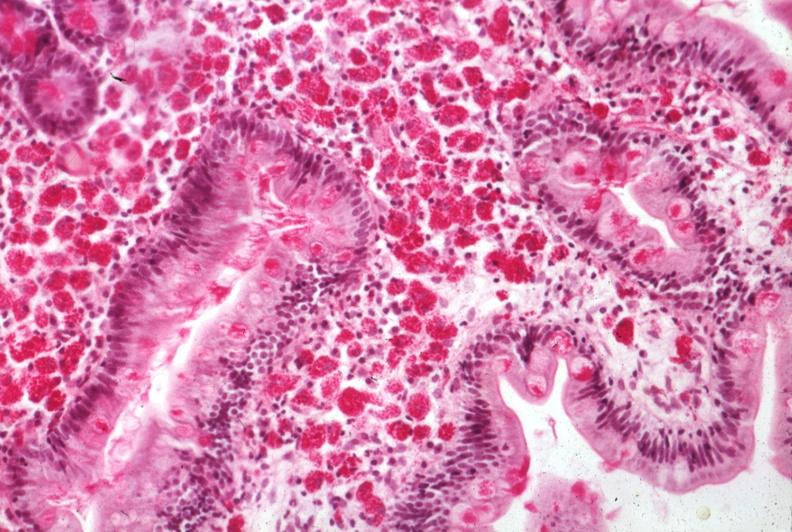does autopsy show med pas hematoxylin section of mucosa excellent example source?
Answer the question using a single word or phrase. No 